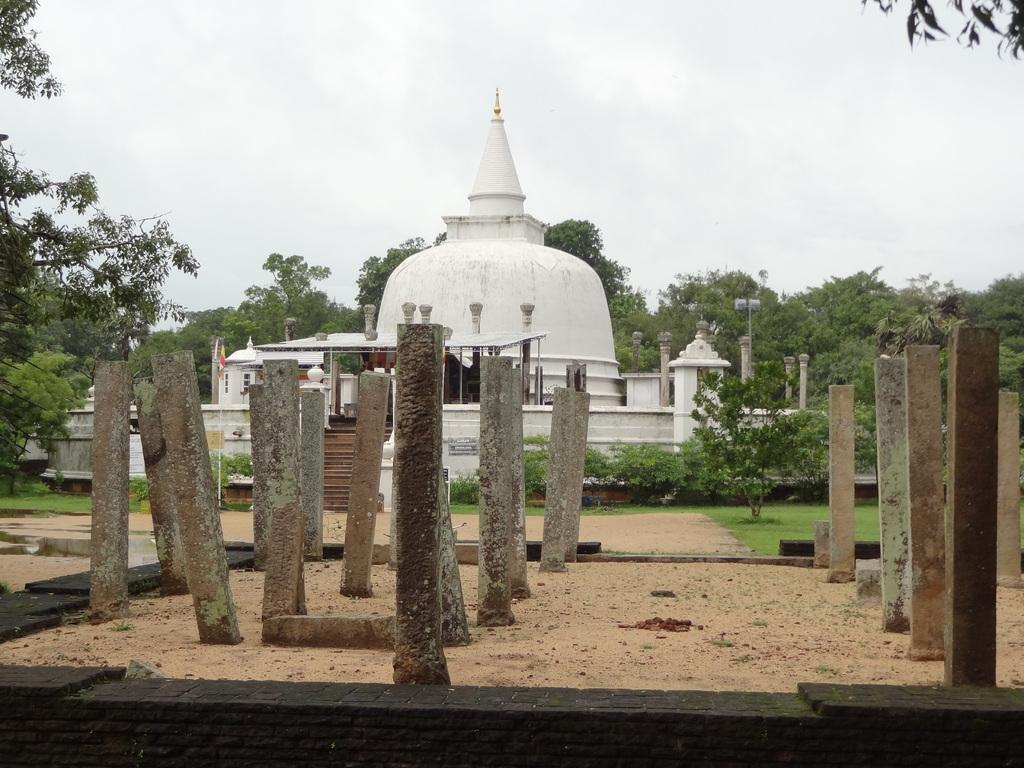What is the main structure in the image? There is a building at the center of the image. What is located in front of the building? There are pillars on a rock structure in front of the building. What can be seen in the background of the image? There are trees and the sky visible in the background of the image. What book is the rabbit reading in the image? There is no book or rabbit present in the image. 